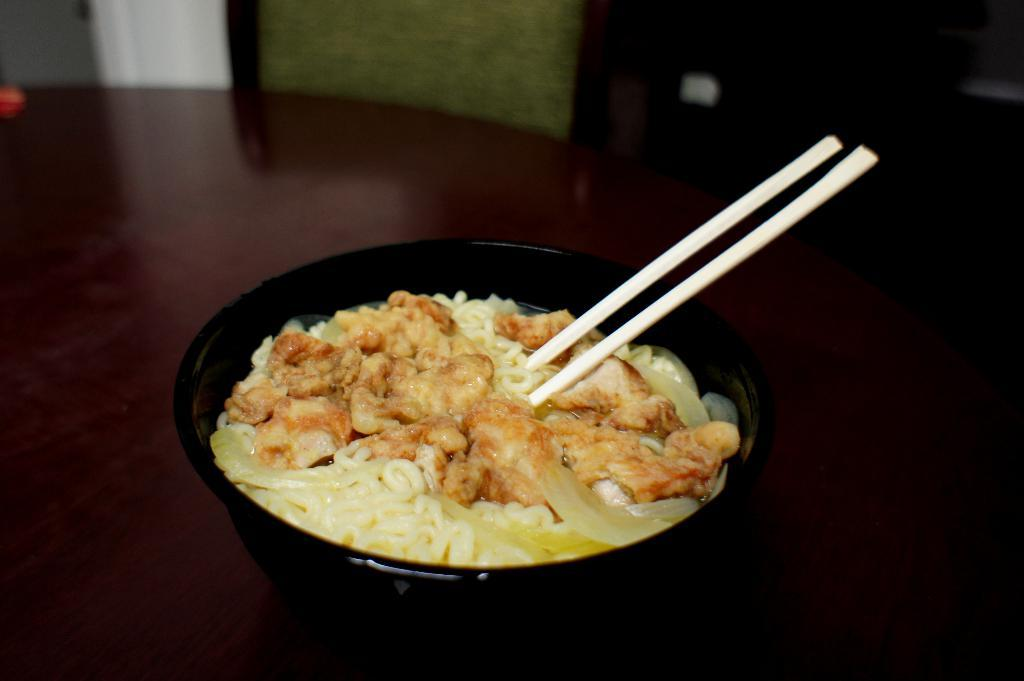What is the main piece of furniture in the image? There is a table in the image. What is placed on the table? There is a cup of noodles on the table. What utensils are provided with the cup of noodles? There are two chopsticks with the cup of noodles. What type of stitch is used to create the sky in the image? There is no sky present in the image, and therefore no stitching can be observed. 